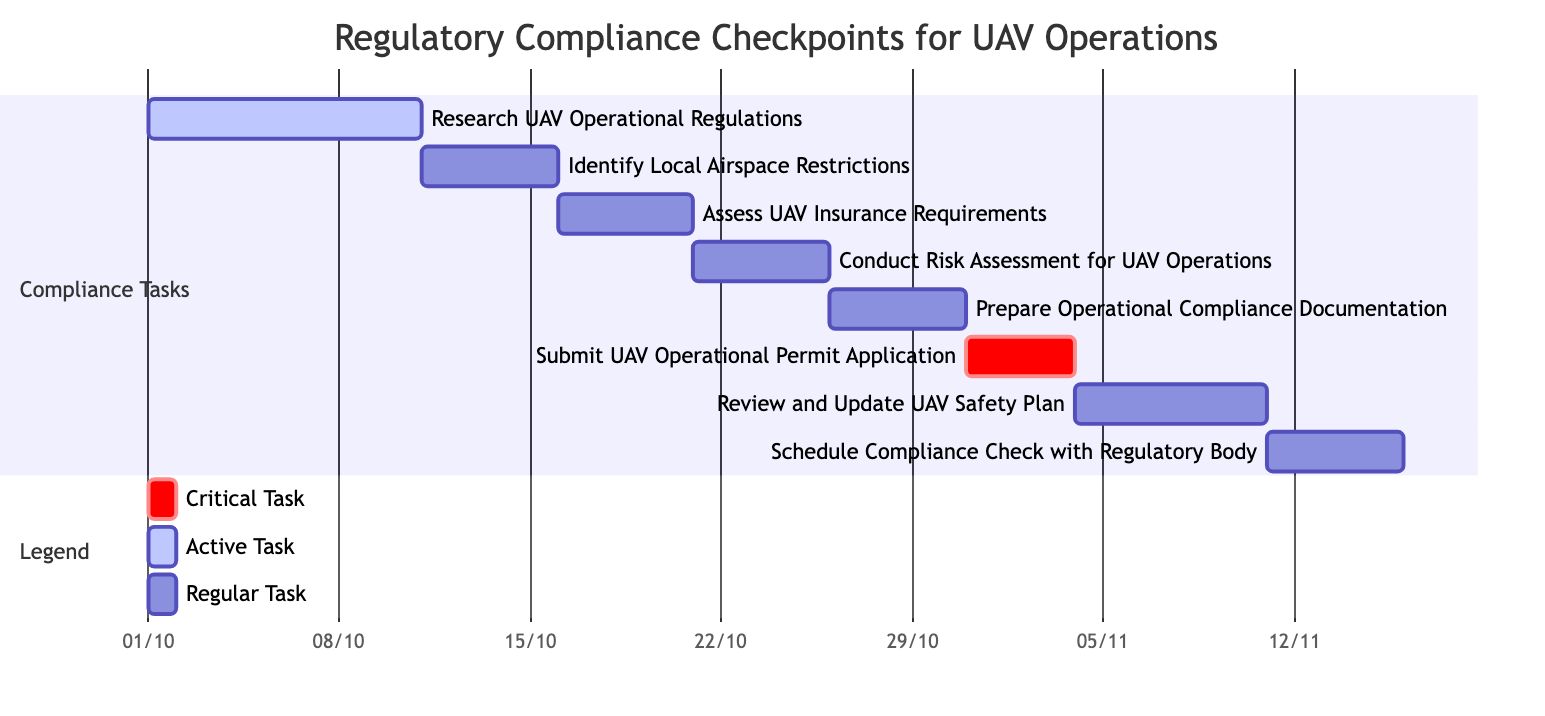What is the duration of the task "Prepare Operational Compliance Documentation"? The task "Prepare Operational Compliance Documentation" is listed in the diagram with a duration of 5 days.
Answer: 5 Days When does the task "Submit UAV Operational Permit Application" start? The task "Submit UAV Operational Permit Application" starts on October 31, 2023, as indicated in the diagram.
Answer: October 31, 2023 Which task follows "Assess UAV Insurance Requirements" in the timeline? The diagram shows that "Conduct Risk Assessment for UAV Operations" follows "Assess UAV Insurance Requirements" as it starts right after on October 21, 2023.
Answer: Conduct Risk Assessment for UAV Operations What is the last task in the compliance process? The last task listed in the compliance process is "Schedule Compliance Check with Regulatory Body," which ends on November 15, 2023.
Answer: Schedule Compliance Check with Regulatory Body How many days are allocated for reviewing and updating the UAV safety plan? The task "Review and Update UAV Safety Plan" is allocated 7 days, as shown in the task's details in the diagram.
Answer: 7 Days Is "Research UAV Operational Regulations" an active task? Yes, "Research UAV Operational Regulations" is marked as an active task in the diagram, which is explicitly indicated.
Answer: Yes How many critical tasks are represented in the Gantt chart? The diagram has one critical task, which is "Submit UAV Operational Permit Application," as signified by its critical designation.
Answer: 1 What starts immediately after "Identify Local Airspace Restrictions"? The task immediately following "Identify Local Airspace Restrictions" is "Assess UAV Insurance Requirements," beginning on October 16, 2023.
Answer: Assess UAV Insurance Requirements Which task has the shortest duration? The task "Submit UAV Operational Permit Application" has the shortest duration of 4 days according to the information presented in the diagram.
Answer: 4 Days 